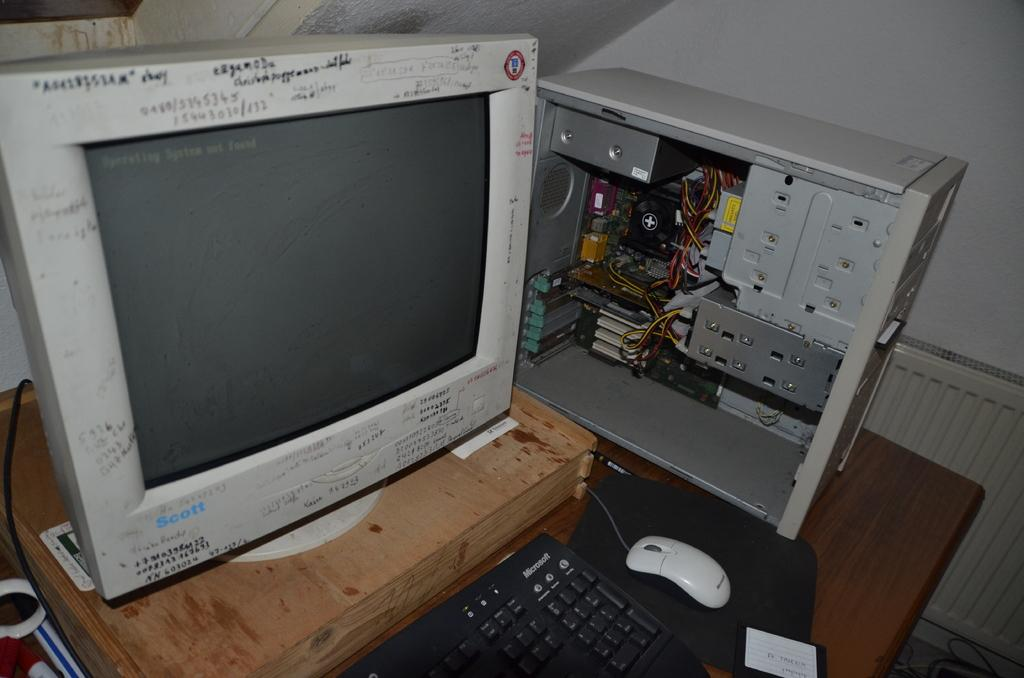<image>
Provide a brief description of the given image. A computer tower and a monitor on a table with Microsoft keyboard. 